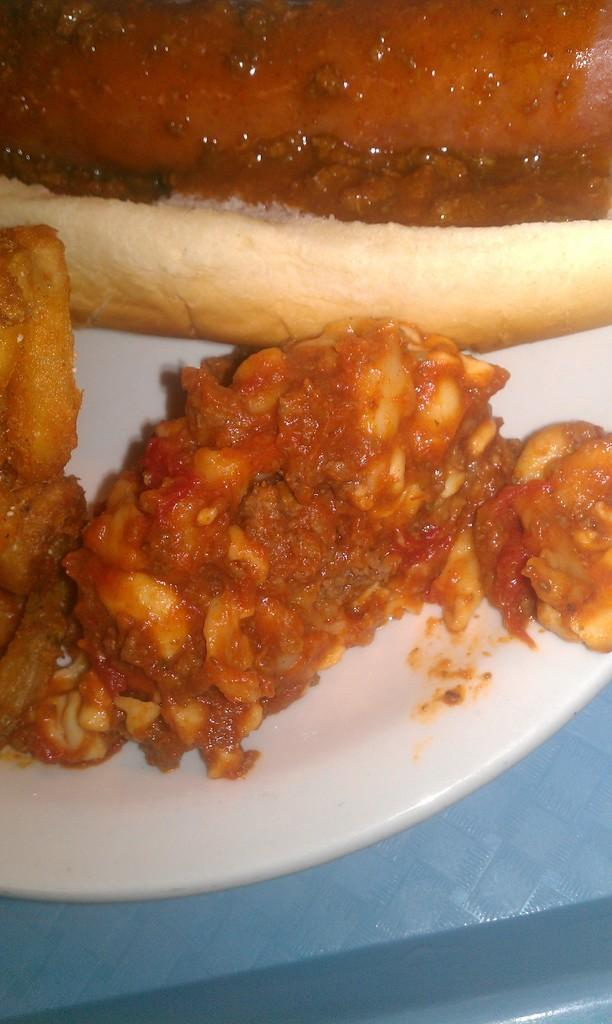What is on the plate that is visible in the image? There is bread on the plate in the image. What else can be seen on the plate besides the bread? There are other food items on the plate in the image. What is the plate resting on in the image? The plate is on an object in the image. What type of card is being used to cut the bread in the image? There is no card present in the image, nor is there any indication of cutting the bread. 